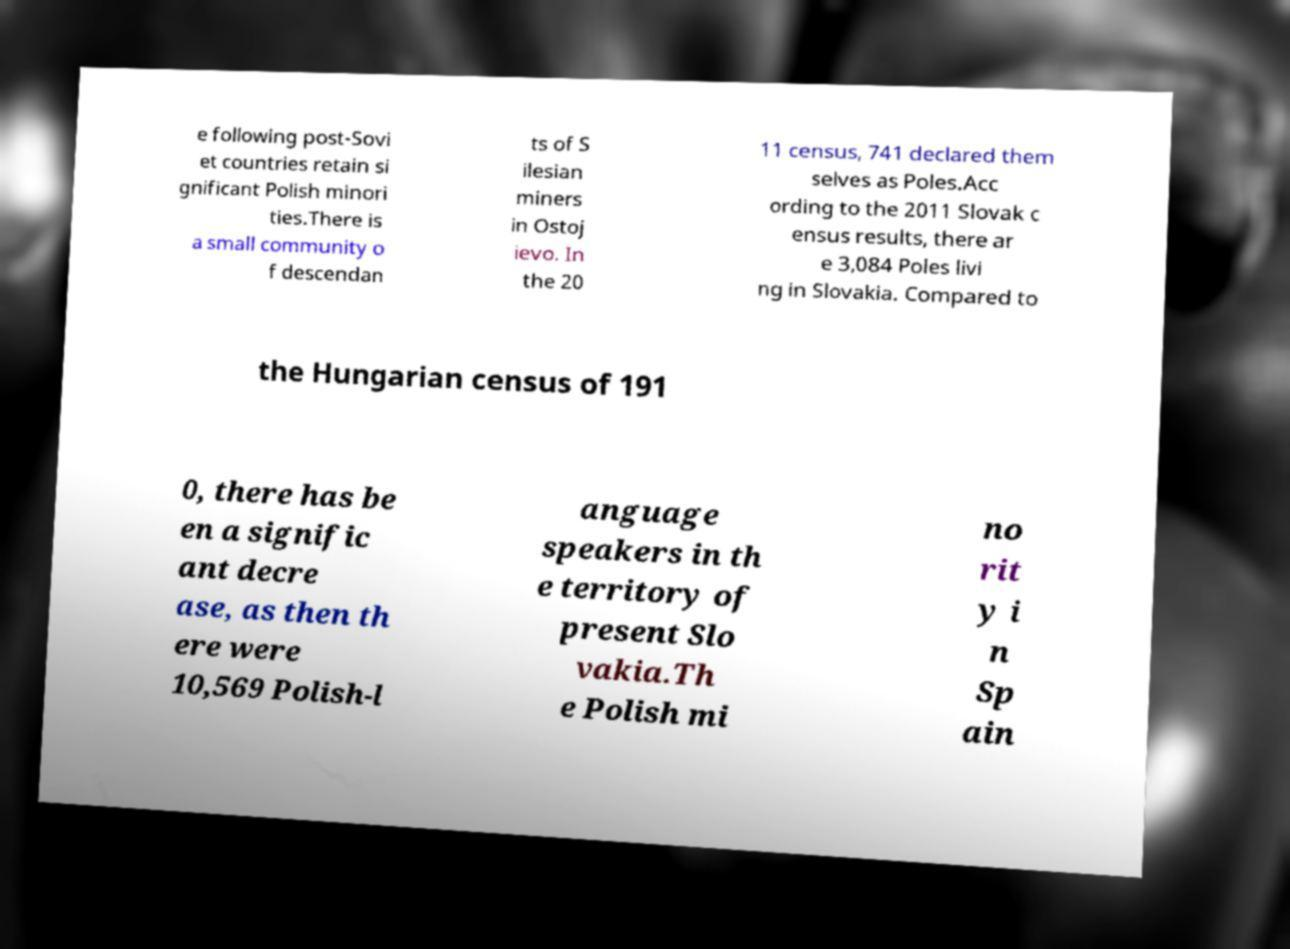For documentation purposes, I need the text within this image transcribed. Could you provide that? e following post-Sovi et countries retain si gnificant Polish minori ties.There is a small community o f descendan ts of S ilesian miners in Ostoj ievo. In the 20 11 census, 741 declared them selves as Poles.Acc ording to the 2011 Slovak c ensus results, there ar e 3,084 Poles livi ng in Slovakia. Compared to the Hungarian census of 191 0, there has be en a signific ant decre ase, as then th ere were 10,569 Polish-l anguage speakers in th e territory of present Slo vakia.Th e Polish mi no rit y i n Sp ain 